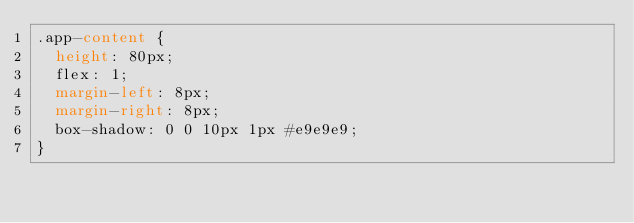<code> <loc_0><loc_0><loc_500><loc_500><_CSS_>.app-content {
  height: 80px;
  flex: 1;
  margin-left: 8px;
  margin-right: 8px;
  box-shadow: 0 0 10px 1px #e9e9e9;
}
</code> 